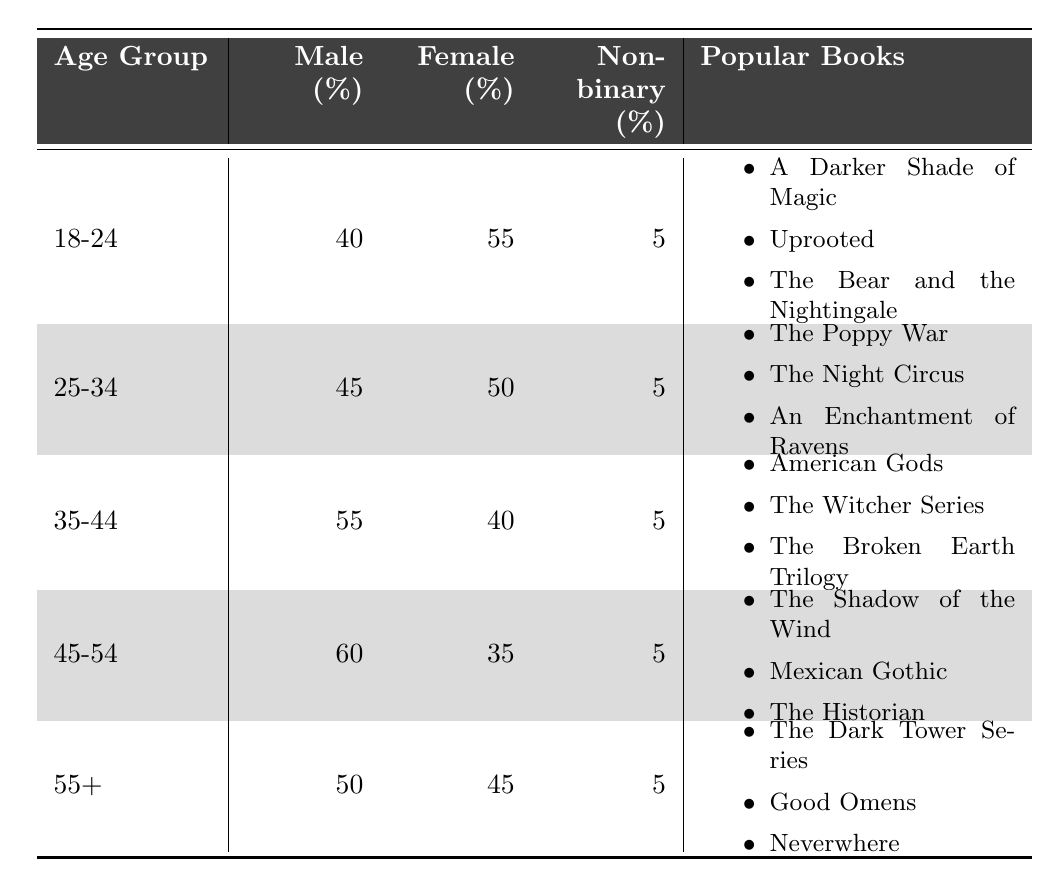What percentage of readers in the 25-34 age group identify as female? According to the table, the percentage of female readers in the 25-34 age group is explicitly listed as 50%.
Answer: 50% Which age group has the highest percentage of male readers? The highest percentage of male readers is in the 45-54 age group, which is 60%.
Answer: 60% What is the total percentage of non-binary readers across all age groups? Since each age group has 5% identified as non-binary, and there are five age groups (5% * 5 = 25%), the total percentage of non-binary readers is 25%.
Answer: 25% Is the percentage of female readers in the 35-44 age group greater than that in the 45-54 age group? The percentage of female readers in the 35-44 age group is 40%, while in the 45-54 age group it is 35%. Since 40% is greater than 35%, the statement is true.
Answer: Yes What is the difference in percentage of male readers between the 35-44 age group and the 18-24 age group? The percentage of male readers in the 35-44 age group is 55%, while in the 18-24 age group it is 40%. The difference is 55% - 40% = 15%.
Answer: 15% What is the average percentage of female readers across all age groups? Adding the percentages of female readers (55 + 50 + 40 + 35 + 45 = 225) and dividing by the number of age groups (225/5 = 45), the average percentage of female readers is 45%.
Answer: 45% In which age group is "The Poppy War" listed as a popular book, and what is the percentage of male readers in that group? "The Poppy War" is a popular book in the 25-34 age group, where the percentage of male readers is 45%.
Answer: 45% Are there more popular books listed for the 55+ age group compared to the 18-24 age group? Both age groups have three popular books listed, indicating they have the same number of popular books. Therefore, it is false that there are more for the 55+ age group.
Answer: No What is the gender distribution percentage of non-binary readers in the 45-54 age group? The table shows that the percentage of non-binary readers in the 45-54 age group is 5%.
Answer: 5% What is the total percentage of male readers in the 18-24 and 25-34 age groups combined? The percentage of male readers in the 18-24 age group is 40% and in the 25-34 age group is 45%. Combining these gives 40% + 45% = 85%.
Answer: 85% Which age group has the least percentage of female readers, and what is that percentage? The age group with the least percentage of female readers is the 45-54 age group, with 35%.
Answer: 35% 